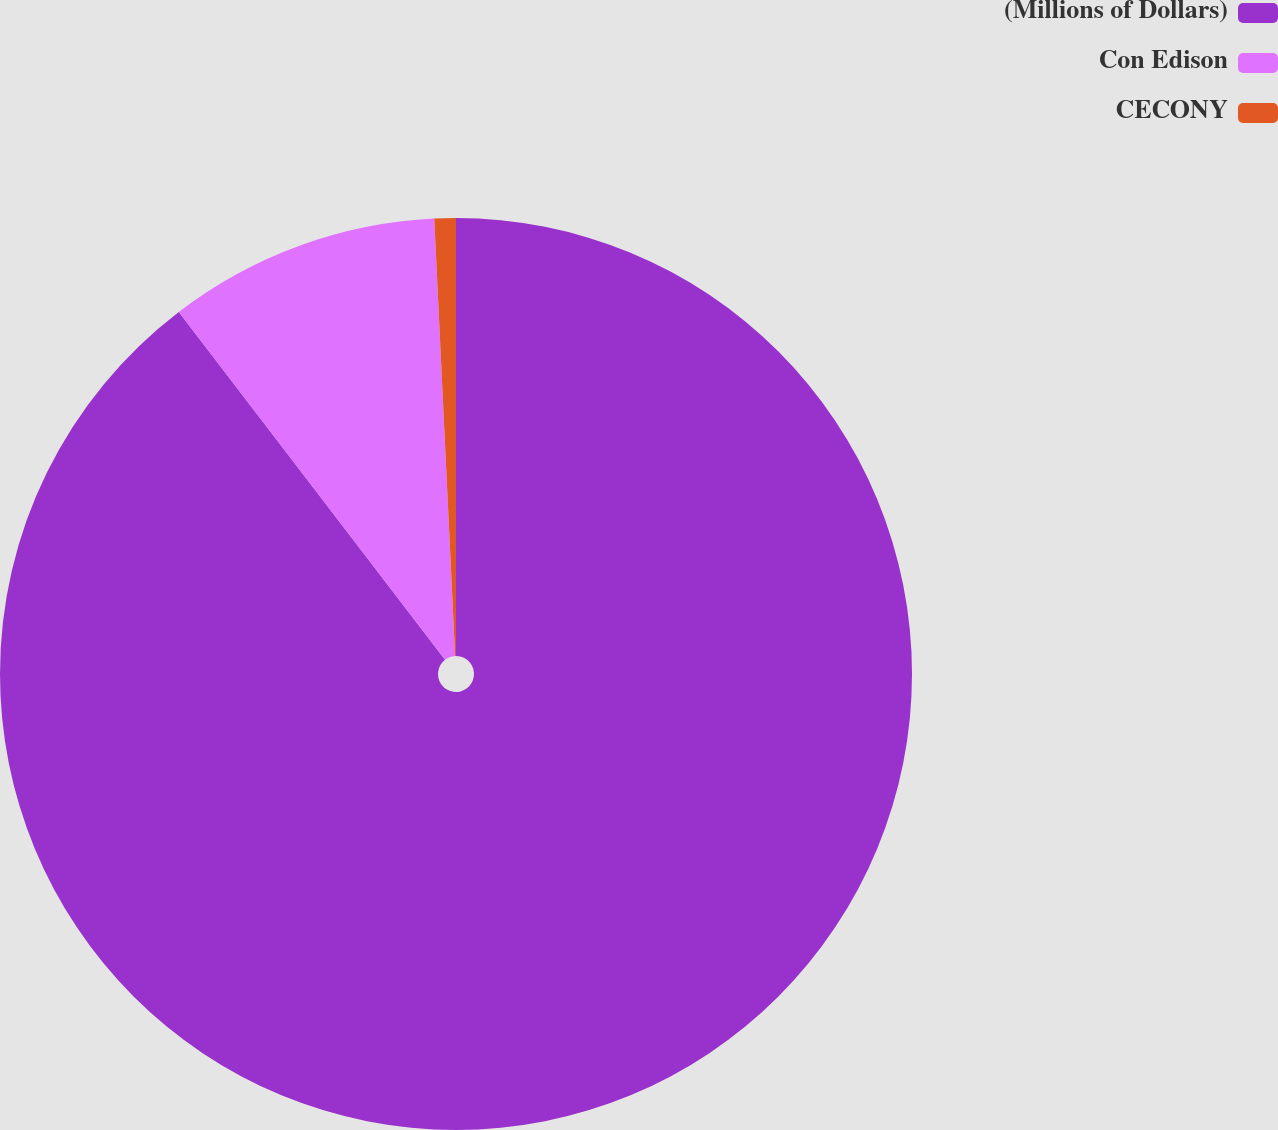Convert chart to OTSL. <chart><loc_0><loc_0><loc_500><loc_500><pie_chart><fcel>(Millions of Dollars)<fcel>Con Edison<fcel>CECONY<nl><fcel>89.6%<fcel>9.64%<fcel>0.76%<nl></chart> 